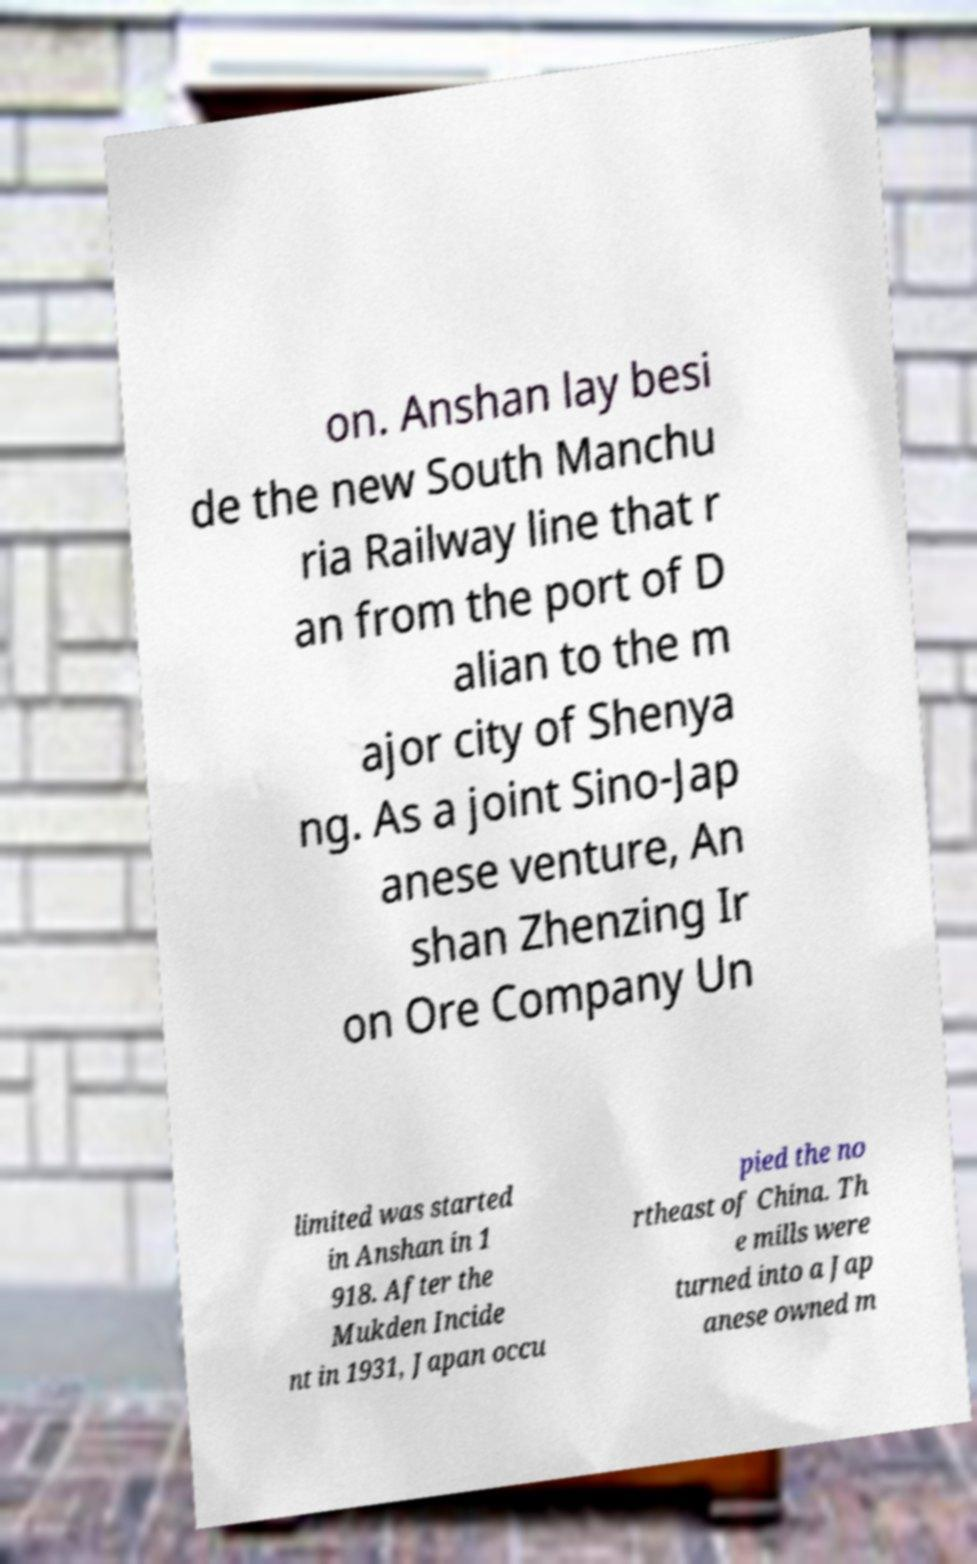What messages or text are displayed in this image? I need them in a readable, typed format. on. Anshan lay besi de the new South Manchu ria Railway line that r an from the port of D alian to the m ajor city of Shenya ng. As a joint Sino-Jap anese venture, An shan Zhenzing Ir on Ore Company Un limited was started in Anshan in 1 918. After the Mukden Incide nt in 1931, Japan occu pied the no rtheast of China. Th e mills were turned into a Jap anese owned m 